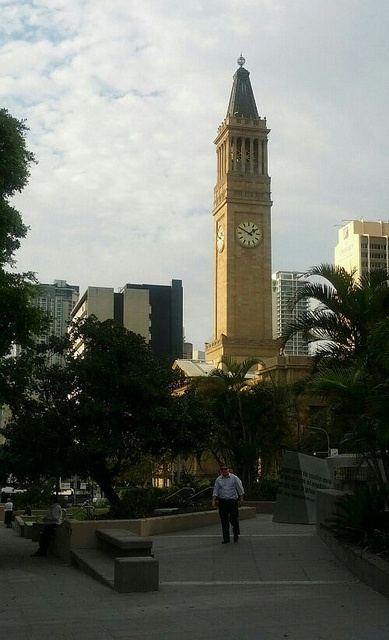Describe the objects in this image and their specific colors. I can see people in lightgray, black, and gray tones, bench in lightgray and black tones, people in lightgray, black, and gray tones, clock in lightgray, gray, olive, darkgreen, and black tones, and people in lightgray, black, gray, and purple tones in this image. 